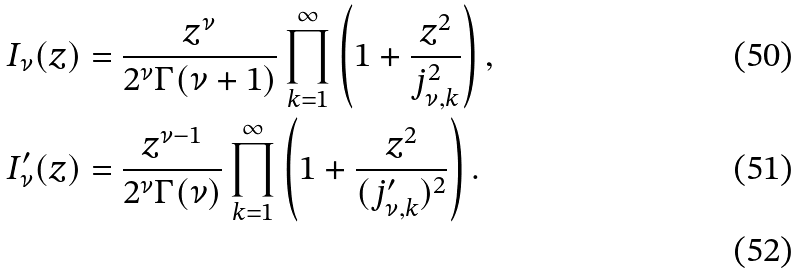<formula> <loc_0><loc_0><loc_500><loc_500>I _ { \nu } ( z ) & = \frac { z ^ { \nu } } { 2 ^ { \nu } \Gamma ( \nu + 1 ) } \prod _ { k = 1 } ^ { \infty } \left ( 1 + \frac { z ^ { 2 } } { j _ { \nu , k } ^ { 2 } } \right ) , \\ I _ { \nu } ^ { \prime } ( z ) & = \frac { z ^ { \nu - 1 } } { 2 ^ { \nu } \Gamma ( \nu ) } \prod _ { k = 1 } ^ { \infty } \left ( 1 + \frac { z ^ { 2 } } { ( j _ { \nu , k } ^ { \prime } ) ^ { 2 } } \right ) . \\</formula> 